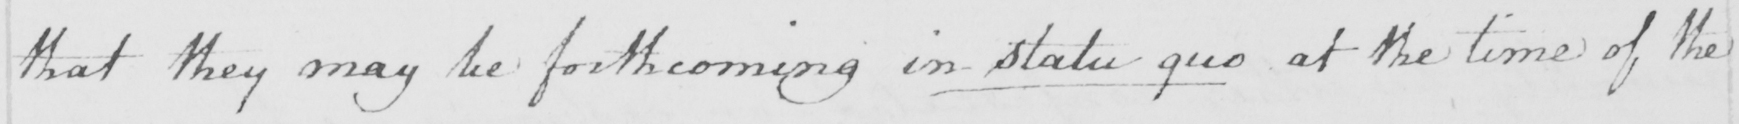Can you read and transcribe this handwriting? that they may be forthcoming in Statu-quo at the time of the 